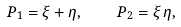<formula> <loc_0><loc_0><loc_500><loc_500>P _ { 1 } = \xi + \eta , \quad P _ { 2 } = \xi \, \eta ,</formula> 